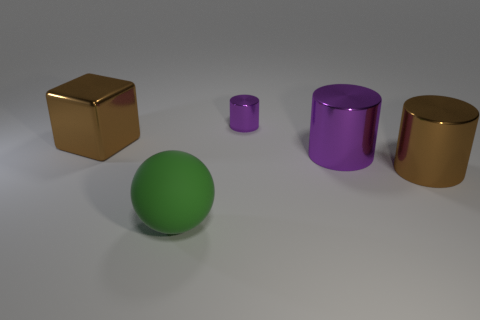There is a brown thing that is left of the cylinder that is on the right side of the large purple cylinder; what is it made of?
Your answer should be compact. Metal. There is a metallic object that is the same color as the big cube; what shape is it?
Offer a terse response. Cylinder. Is there a large brown thing that has the same material as the green sphere?
Offer a terse response. No. Are the small cylinder and the brown object that is in front of the metallic block made of the same material?
Your answer should be very brief. Yes. What color is the shiny block that is the same size as the rubber thing?
Ensure brevity in your answer.  Brown. What size is the thing in front of the large brown metal thing to the right of the green rubber object?
Give a very brief answer. Large. Do the big metal block and the shiny cylinder that is behind the big brown block have the same color?
Your response must be concise. No. Are there fewer large purple cylinders that are behind the large purple metal cylinder than big metal blocks?
Your answer should be very brief. Yes. What number of other objects are the same size as the green rubber thing?
Ensure brevity in your answer.  3. Do the brown object on the left side of the large green rubber thing and the green rubber object have the same shape?
Your response must be concise. No. 